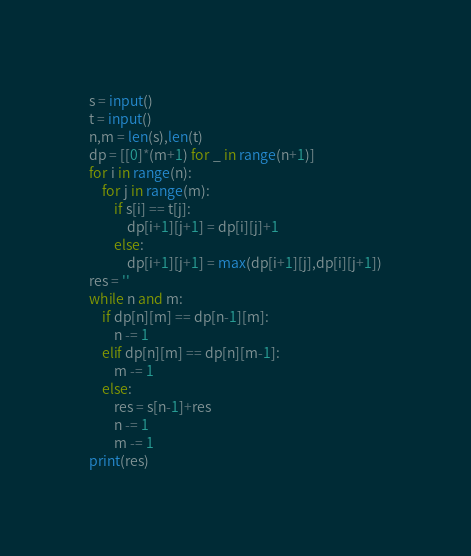Convert code to text. <code><loc_0><loc_0><loc_500><loc_500><_Python_>s = input()
t = input()
n,m = len(s),len(t)
dp = [[0]*(m+1) for _ in range(n+1)]
for i in range(n):
    for j in range(m):
        if s[i] == t[j]:
            dp[i+1][j+1] = dp[i][j]+1
        else:
            dp[i+1][j+1] = max(dp[i+1][j],dp[i][j+1])
res = ''
while n and m:
    if dp[n][m] == dp[n-1][m]:
        n -= 1
    elif dp[n][m] == dp[n][m-1]:
        m -= 1
    else:
        res = s[n-1]+res
        n -= 1
        m -= 1
print(res)
</code> 